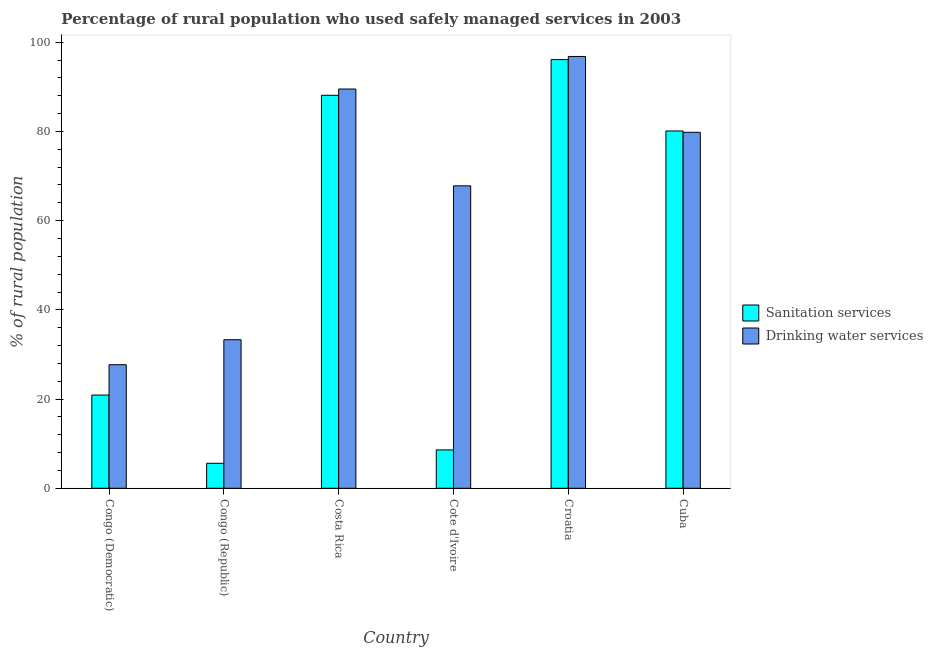How many groups of bars are there?
Give a very brief answer. 6. Are the number of bars on each tick of the X-axis equal?
Give a very brief answer. Yes. What is the label of the 3rd group of bars from the left?
Your answer should be compact. Costa Rica. What is the percentage of rural population who used drinking water services in Congo (Democratic)?
Make the answer very short. 27.7. Across all countries, what is the maximum percentage of rural population who used sanitation services?
Your answer should be very brief. 96.1. Across all countries, what is the minimum percentage of rural population who used drinking water services?
Keep it short and to the point. 27.7. In which country was the percentage of rural population who used sanitation services maximum?
Make the answer very short. Croatia. In which country was the percentage of rural population who used sanitation services minimum?
Provide a succinct answer. Congo (Republic). What is the total percentage of rural population who used drinking water services in the graph?
Your answer should be very brief. 394.9. What is the difference between the percentage of rural population who used drinking water services in Congo (Republic) and that in Costa Rica?
Keep it short and to the point. -56.2. What is the difference between the percentage of rural population who used drinking water services in Croatia and the percentage of rural population who used sanitation services in Cote d'Ivoire?
Your response must be concise. 88.2. What is the average percentage of rural population who used sanitation services per country?
Your response must be concise. 49.9. What is the difference between the percentage of rural population who used sanitation services and percentage of rural population who used drinking water services in Cuba?
Ensure brevity in your answer.  0.3. In how many countries, is the percentage of rural population who used sanitation services greater than 8 %?
Keep it short and to the point. 5. What is the ratio of the percentage of rural population who used sanitation services in Congo (Democratic) to that in Congo (Republic)?
Offer a very short reply. 3.73. Is the percentage of rural population who used sanitation services in Cote d'Ivoire less than that in Croatia?
Keep it short and to the point. Yes. What is the difference between the highest and the second highest percentage of rural population who used sanitation services?
Make the answer very short. 8. What is the difference between the highest and the lowest percentage of rural population who used sanitation services?
Ensure brevity in your answer.  90.5. In how many countries, is the percentage of rural population who used sanitation services greater than the average percentage of rural population who used sanitation services taken over all countries?
Offer a terse response. 3. Is the sum of the percentage of rural population who used sanitation services in Cote d'Ivoire and Croatia greater than the maximum percentage of rural population who used drinking water services across all countries?
Offer a very short reply. Yes. What does the 1st bar from the left in Congo (Democratic) represents?
Your response must be concise. Sanitation services. What does the 1st bar from the right in Costa Rica represents?
Give a very brief answer. Drinking water services. How many bars are there?
Provide a succinct answer. 12. How many countries are there in the graph?
Provide a short and direct response. 6. What is the difference between two consecutive major ticks on the Y-axis?
Your answer should be very brief. 20. Are the values on the major ticks of Y-axis written in scientific E-notation?
Offer a terse response. No. Does the graph contain any zero values?
Provide a succinct answer. No. Does the graph contain grids?
Your response must be concise. No. Where does the legend appear in the graph?
Provide a succinct answer. Center right. How many legend labels are there?
Give a very brief answer. 2. How are the legend labels stacked?
Ensure brevity in your answer.  Vertical. What is the title of the graph?
Keep it short and to the point. Percentage of rural population who used safely managed services in 2003. What is the label or title of the Y-axis?
Provide a short and direct response. % of rural population. What is the % of rural population in Sanitation services in Congo (Democratic)?
Your answer should be very brief. 20.9. What is the % of rural population in Drinking water services in Congo (Democratic)?
Your answer should be compact. 27.7. What is the % of rural population in Drinking water services in Congo (Republic)?
Your answer should be very brief. 33.3. What is the % of rural population in Sanitation services in Costa Rica?
Offer a terse response. 88.1. What is the % of rural population of Drinking water services in Costa Rica?
Your answer should be very brief. 89.5. What is the % of rural population in Sanitation services in Cote d'Ivoire?
Keep it short and to the point. 8.6. What is the % of rural population in Drinking water services in Cote d'Ivoire?
Provide a succinct answer. 67.8. What is the % of rural population in Sanitation services in Croatia?
Ensure brevity in your answer.  96.1. What is the % of rural population of Drinking water services in Croatia?
Make the answer very short. 96.8. What is the % of rural population of Sanitation services in Cuba?
Offer a very short reply. 80.1. What is the % of rural population in Drinking water services in Cuba?
Ensure brevity in your answer.  79.8. Across all countries, what is the maximum % of rural population in Sanitation services?
Keep it short and to the point. 96.1. Across all countries, what is the maximum % of rural population of Drinking water services?
Keep it short and to the point. 96.8. Across all countries, what is the minimum % of rural population of Sanitation services?
Keep it short and to the point. 5.6. Across all countries, what is the minimum % of rural population in Drinking water services?
Offer a very short reply. 27.7. What is the total % of rural population of Sanitation services in the graph?
Offer a very short reply. 299.4. What is the total % of rural population in Drinking water services in the graph?
Your response must be concise. 394.9. What is the difference between the % of rural population in Sanitation services in Congo (Democratic) and that in Congo (Republic)?
Ensure brevity in your answer.  15.3. What is the difference between the % of rural population of Drinking water services in Congo (Democratic) and that in Congo (Republic)?
Your response must be concise. -5.6. What is the difference between the % of rural population of Sanitation services in Congo (Democratic) and that in Costa Rica?
Give a very brief answer. -67.2. What is the difference between the % of rural population of Drinking water services in Congo (Democratic) and that in Costa Rica?
Offer a very short reply. -61.8. What is the difference between the % of rural population of Sanitation services in Congo (Democratic) and that in Cote d'Ivoire?
Keep it short and to the point. 12.3. What is the difference between the % of rural population of Drinking water services in Congo (Democratic) and that in Cote d'Ivoire?
Keep it short and to the point. -40.1. What is the difference between the % of rural population of Sanitation services in Congo (Democratic) and that in Croatia?
Keep it short and to the point. -75.2. What is the difference between the % of rural population in Drinking water services in Congo (Democratic) and that in Croatia?
Offer a very short reply. -69.1. What is the difference between the % of rural population of Sanitation services in Congo (Democratic) and that in Cuba?
Ensure brevity in your answer.  -59.2. What is the difference between the % of rural population in Drinking water services in Congo (Democratic) and that in Cuba?
Your response must be concise. -52.1. What is the difference between the % of rural population of Sanitation services in Congo (Republic) and that in Costa Rica?
Your answer should be compact. -82.5. What is the difference between the % of rural population of Drinking water services in Congo (Republic) and that in Costa Rica?
Make the answer very short. -56.2. What is the difference between the % of rural population of Drinking water services in Congo (Republic) and that in Cote d'Ivoire?
Give a very brief answer. -34.5. What is the difference between the % of rural population in Sanitation services in Congo (Republic) and that in Croatia?
Your answer should be compact. -90.5. What is the difference between the % of rural population in Drinking water services in Congo (Republic) and that in Croatia?
Give a very brief answer. -63.5. What is the difference between the % of rural population in Sanitation services in Congo (Republic) and that in Cuba?
Offer a very short reply. -74.5. What is the difference between the % of rural population in Drinking water services in Congo (Republic) and that in Cuba?
Ensure brevity in your answer.  -46.5. What is the difference between the % of rural population in Sanitation services in Costa Rica and that in Cote d'Ivoire?
Your answer should be compact. 79.5. What is the difference between the % of rural population of Drinking water services in Costa Rica and that in Cote d'Ivoire?
Provide a short and direct response. 21.7. What is the difference between the % of rural population of Sanitation services in Costa Rica and that in Croatia?
Give a very brief answer. -8. What is the difference between the % of rural population in Drinking water services in Costa Rica and that in Croatia?
Provide a succinct answer. -7.3. What is the difference between the % of rural population in Sanitation services in Costa Rica and that in Cuba?
Ensure brevity in your answer.  8. What is the difference between the % of rural population of Drinking water services in Costa Rica and that in Cuba?
Keep it short and to the point. 9.7. What is the difference between the % of rural population of Sanitation services in Cote d'Ivoire and that in Croatia?
Keep it short and to the point. -87.5. What is the difference between the % of rural population in Drinking water services in Cote d'Ivoire and that in Croatia?
Offer a very short reply. -29. What is the difference between the % of rural population in Sanitation services in Cote d'Ivoire and that in Cuba?
Your answer should be very brief. -71.5. What is the difference between the % of rural population in Sanitation services in Croatia and that in Cuba?
Your answer should be compact. 16. What is the difference between the % of rural population in Drinking water services in Croatia and that in Cuba?
Provide a short and direct response. 17. What is the difference between the % of rural population of Sanitation services in Congo (Democratic) and the % of rural population of Drinking water services in Congo (Republic)?
Provide a short and direct response. -12.4. What is the difference between the % of rural population of Sanitation services in Congo (Democratic) and the % of rural population of Drinking water services in Costa Rica?
Offer a terse response. -68.6. What is the difference between the % of rural population of Sanitation services in Congo (Democratic) and the % of rural population of Drinking water services in Cote d'Ivoire?
Your answer should be compact. -46.9. What is the difference between the % of rural population of Sanitation services in Congo (Democratic) and the % of rural population of Drinking water services in Croatia?
Your response must be concise. -75.9. What is the difference between the % of rural population of Sanitation services in Congo (Democratic) and the % of rural population of Drinking water services in Cuba?
Your answer should be very brief. -58.9. What is the difference between the % of rural population in Sanitation services in Congo (Republic) and the % of rural population in Drinking water services in Costa Rica?
Make the answer very short. -83.9. What is the difference between the % of rural population of Sanitation services in Congo (Republic) and the % of rural population of Drinking water services in Cote d'Ivoire?
Keep it short and to the point. -62.2. What is the difference between the % of rural population of Sanitation services in Congo (Republic) and the % of rural population of Drinking water services in Croatia?
Keep it short and to the point. -91.2. What is the difference between the % of rural population in Sanitation services in Congo (Republic) and the % of rural population in Drinking water services in Cuba?
Your response must be concise. -74.2. What is the difference between the % of rural population of Sanitation services in Costa Rica and the % of rural population of Drinking water services in Cote d'Ivoire?
Ensure brevity in your answer.  20.3. What is the difference between the % of rural population in Sanitation services in Costa Rica and the % of rural population in Drinking water services in Croatia?
Provide a succinct answer. -8.7. What is the difference between the % of rural population in Sanitation services in Cote d'Ivoire and the % of rural population in Drinking water services in Croatia?
Ensure brevity in your answer.  -88.2. What is the difference between the % of rural population in Sanitation services in Cote d'Ivoire and the % of rural population in Drinking water services in Cuba?
Your answer should be very brief. -71.2. What is the average % of rural population in Sanitation services per country?
Offer a terse response. 49.9. What is the average % of rural population in Drinking water services per country?
Provide a succinct answer. 65.82. What is the difference between the % of rural population in Sanitation services and % of rural population in Drinking water services in Congo (Democratic)?
Your answer should be compact. -6.8. What is the difference between the % of rural population of Sanitation services and % of rural population of Drinking water services in Congo (Republic)?
Provide a short and direct response. -27.7. What is the difference between the % of rural population in Sanitation services and % of rural population in Drinking water services in Costa Rica?
Offer a terse response. -1.4. What is the difference between the % of rural population of Sanitation services and % of rural population of Drinking water services in Cote d'Ivoire?
Offer a very short reply. -59.2. What is the difference between the % of rural population of Sanitation services and % of rural population of Drinking water services in Croatia?
Make the answer very short. -0.7. What is the difference between the % of rural population of Sanitation services and % of rural population of Drinking water services in Cuba?
Your response must be concise. 0.3. What is the ratio of the % of rural population of Sanitation services in Congo (Democratic) to that in Congo (Republic)?
Your answer should be very brief. 3.73. What is the ratio of the % of rural population of Drinking water services in Congo (Democratic) to that in Congo (Republic)?
Provide a short and direct response. 0.83. What is the ratio of the % of rural population of Sanitation services in Congo (Democratic) to that in Costa Rica?
Your response must be concise. 0.24. What is the ratio of the % of rural population in Drinking water services in Congo (Democratic) to that in Costa Rica?
Offer a very short reply. 0.31. What is the ratio of the % of rural population in Sanitation services in Congo (Democratic) to that in Cote d'Ivoire?
Provide a succinct answer. 2.43. What is the ratio of the % of rural population in Drinking water services in Congo (Democratic) to that in Cote d'Ivoire?
Keep it short and to the point. 0.41. What is the ratio of the % of rural population of Sanitation services in Congo (Democratic) to that in Croatia?
Provide a succinct answer. 0.22. What is the ratio of the % of rural population of Drinking water services in Congo (Democratic) to that in Croatia?
Your response must be concise. 0.29. What is the ratio of the % of rural population of Sanitation services in Congo (Democratic) to that in Cuba?
Your response must be concise. 0.26. What is the ratio of the % of rural population of Drinking water services in Congo (Democratic) to that in Cuba?
Provide a succinct answer. 0.35. What is the ratio of the % of rural population of Sanitation services in Congo (Republic) to that in Costa Rica?
Offer a terse response. 0.06. What is the ratio of the % of rural population of Drinking water services in Congo (Republic) to that in Costa Rica?
Your answer should be compact. 0.37. What is the ratio of the % of rural population of Sanitation services in Congo (Republic) to that in Cote d'Ivoire?
Your answer should be very brief. 0.65. What is the ratio of the % of rural population of Drinking water services in Congo (Republic) to that in Cote d'Ivoire?
Make the answer very short. 0.49. What is the ratio of the % of rural population of Sanitation services in Congo (Republic) to that in Croatia?
Provide a succinct answer. 0.06. What is the ratio of the % of rural population of Drinking water services in Congo (Republic) to that in Croatia?
Ensure brevity in your answer.  0.34. What is the ratio of the % of rural population in Sanitation services in Congo (Republic) to that in Cuba?
Provide a short and direct response. 0.07. What is the ratio of the % of rural population in Drinking water services in Congo (Republic) to that in Cuba?
Ensure brevity in your answer.  0.42. What is the ratio of the % of rural population in Sanitation services in Costa Rica to that in Cote d'Ivoire?
Ensure brevity in your answer.  10.24. What is the ratio of the % of rural population of Drinking water services in Costa Rica to that in Cote d'Ivoire?
Your answer should be very brief. 1.32. What is the ratio of the % of rural population in Sanitation services in Costa Rica to that in Croatia?
Give a very brief answer. 0.92. What is the ratio of the % of rural population of Drinking water services in Costa Rica to that in Croatia?
Your response must be concise. 0.92. What is the ratio of the % of rural population of Sanitation services in Costa Rica to that in Cuba?
Provide a succinct answer. 1.1. What is the ratio of the % of rural population in Drinking water services in Costa Rica to that in Cuba?
Your answer should be compact. 1.12. What is the ratio of the % of rural population of Sanitation services in Cote d'Ivoire to that in Croatia?
Keep it short and to the point. 0.09. What is the ratio of the % of rural population in Drinking water services in Cote d'Ivoire to that in Croatia?
Ensure brevity in your answer.  0.7. What is the ratio of the % of rural population in Sanitation services in Cote d'Ivoire to that in Cuba?
Provide a succinct answer. 0.11. What is the ratio of the % of rural population in Drinking water services in Cote d'Ivoire to that in Cuba?
Give a very brief answer. 0.85. What is the ratio of the % of rural population of Sanitation services in Croatia to that in Cuba?
Your answer should be very brief. 1.2. What is the ratio of the % of rural population of Drinking water services in Croatia to that in Cuba?
Offer a very short reply. 1.21. What is the difference between the highest and the second highest % of rural population in Sanitation services?
Offer a very short reply. 8. What is the difference between the highest and the lowest % of rural population in Sanitation services?
Your response must be concise. 90.5. What is the difference between the highest and the lowest % of rural population in Drinking water services?
Make the answer very short. 69.1. 